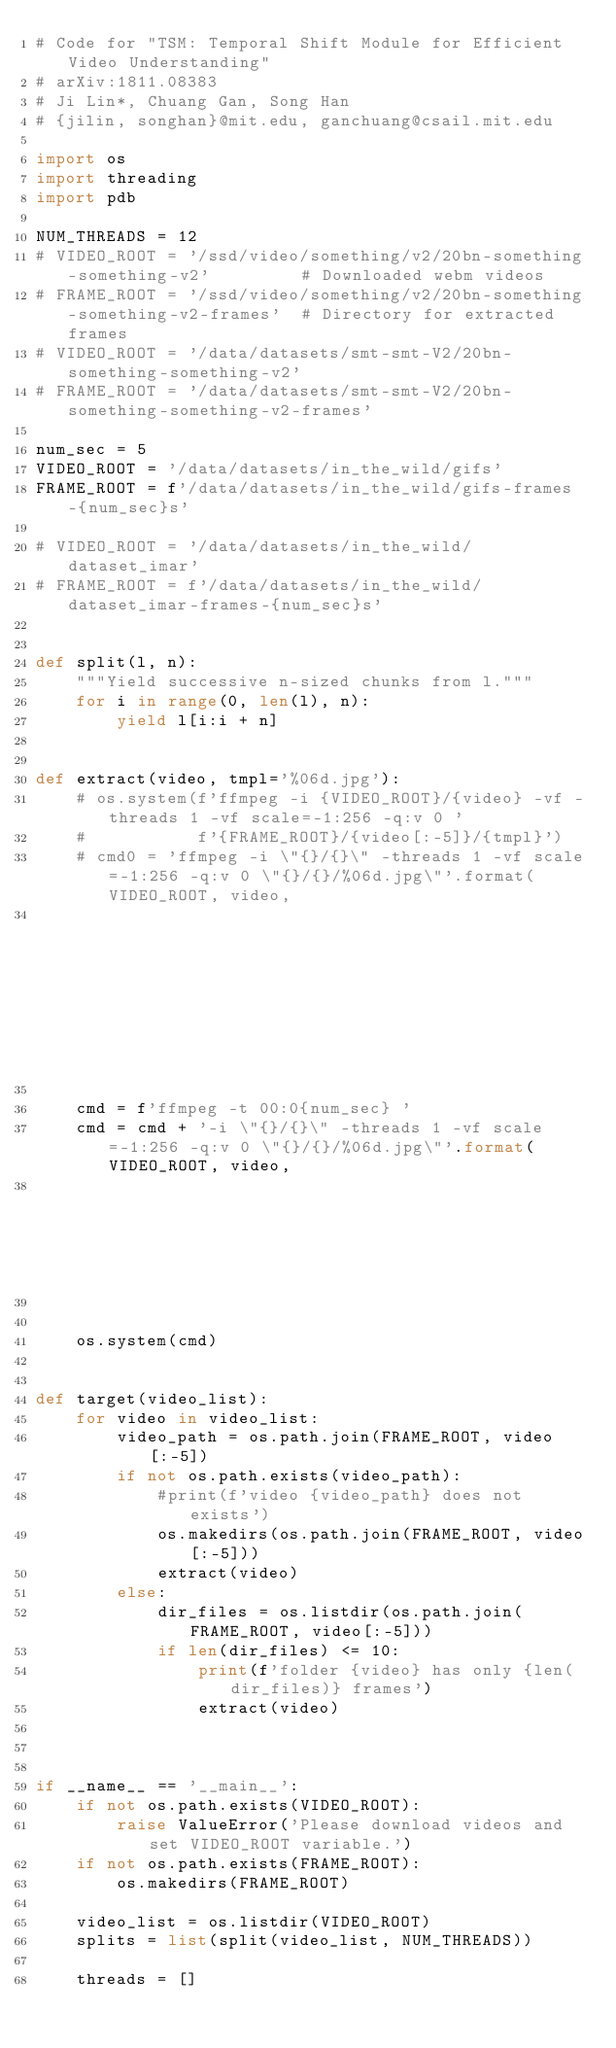<code> <loc_0><loc_0><loc_500><loc_500><_Python_># Code for "TSM: Temporal Shift Module for Efficient Video Understanding"
# arXiv:1811.08383
# Ji Lin*, Chuang Gan, Song Han
# {jilin, songhan}@mit.edu, ganchuang@csail.mit.edu

import os
import threading
import pdb

NUM_THREADS = 12
# VIDEO_ROOT = '/ssd/video/something/v2/20bn-something-something-v2'         # Downloaded webm videos
# FRAME_ROOT = '/ssd/video/something/v2/20bn-something-something-v2-frames'  # Directory for extracted frames
# VIDEO_ROOT = '/data/datasets/smt-smt-V2/20bn-something-something-v2'
# FRAME_ROOT = '/data/datasets/smt-smt-V2/20bn-something-something-v2-frames'

num_sec = 5
VIDEO_ROOT = '/data/datasets/in_the_wild/gifs'
FRAME_ROOT = f'/data/datasets/in_the_wild/gifs-frames-{num_sec}s'

# VIDEO_ROOT = '/data/datasets/in_the_wild/dataset_imar'
# FRAME_ROOT = f'/data/datasets/in_the_wild/dataset_imar-frames-{num_sec}s'


def split(l, n):
    """Yield successive n-sized chunks from l."""
    for i in range(0, len(l), n):
        yield l[i:i + n]


def extract(video, tmpl='%06d.jpg'):
    # os.system(f'ffmpeg -i {VIDEO_ROOT}/{video} -vf -threads 1 -vf scale=-1:256 -q:v 0 '
    #           f'{FRAME_ROOT}/{video[:-5]}/{tmpl}')
    # cmd0 = 'ffmpeg -i \"{}/{}\" -threads 1 -vf scale=-1:256 -q:v 0 \"{}/{}/%06d.jpg\"'.format(VIDEO_ROOT, video,
                                                                                            #  FRAME_ROOT, video[:-5])
    
    cmd = f'ffmpeg -t 00:0{num_sec} '
    cmd = cmd + '-i \"{}/{}\" -threads 1 -vf scale=-1:256 -q:v 0 \"{}/{}/%06d.jpg\"'.format(VIDEO_ROOT, video,
                                                                                             FRAME_ROOT, video[:-5])
   
    
    os.system(cmd)


def target(video_list):
    for video in video_list:
        video_path = os.path.join(FRAME_ROOT, video[:-5])
        if not os.path.exists(video_path):
            #print(f'video {video_path} does not exists')
            os.makedirs(os.path.join(FRAME_ROOT, video[:-5]))
            extract(video)
        else:
            dir_files = os.listdir(os.path.join(FRAME_ROOT, video[:-5]))
            if len(dir_files) <= 10:
                print(f'folder {video} has only {len(dir_files)} frames')
                extract(video)



if __name__ == '__main__':
    if not os.path.exists(VIDEO_ROOT):
        raise ValueError('Please download videos and set VIDEO_ROOT variable.')
    if not os.path.exists(FRAME_ROOT):
        os.makedirs(FRAME_ROOT)

    video_list = os.listdir(VIDEO_ROOT)
    splits = list(split(video_list, NUM_THREADS))

    threads = []</code> 